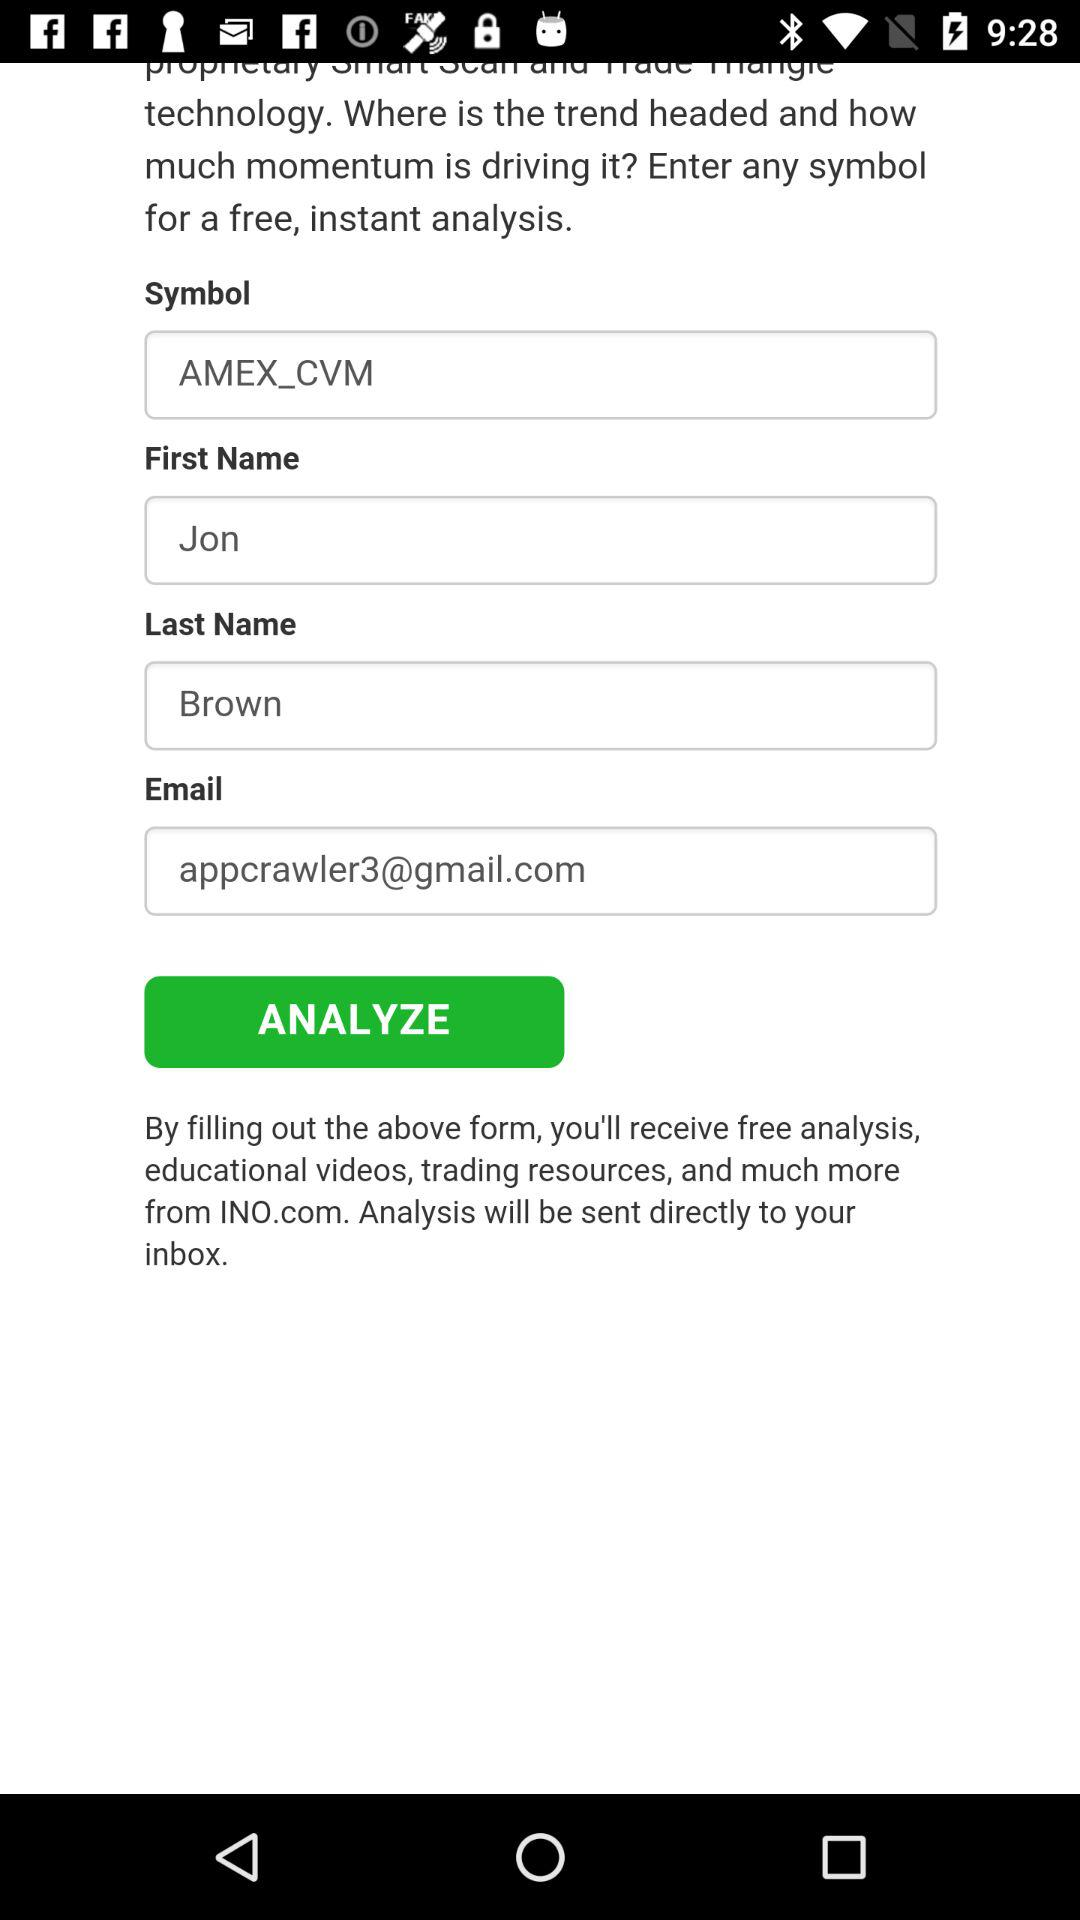What is the first name of the user? The first name of the user is Jon. 